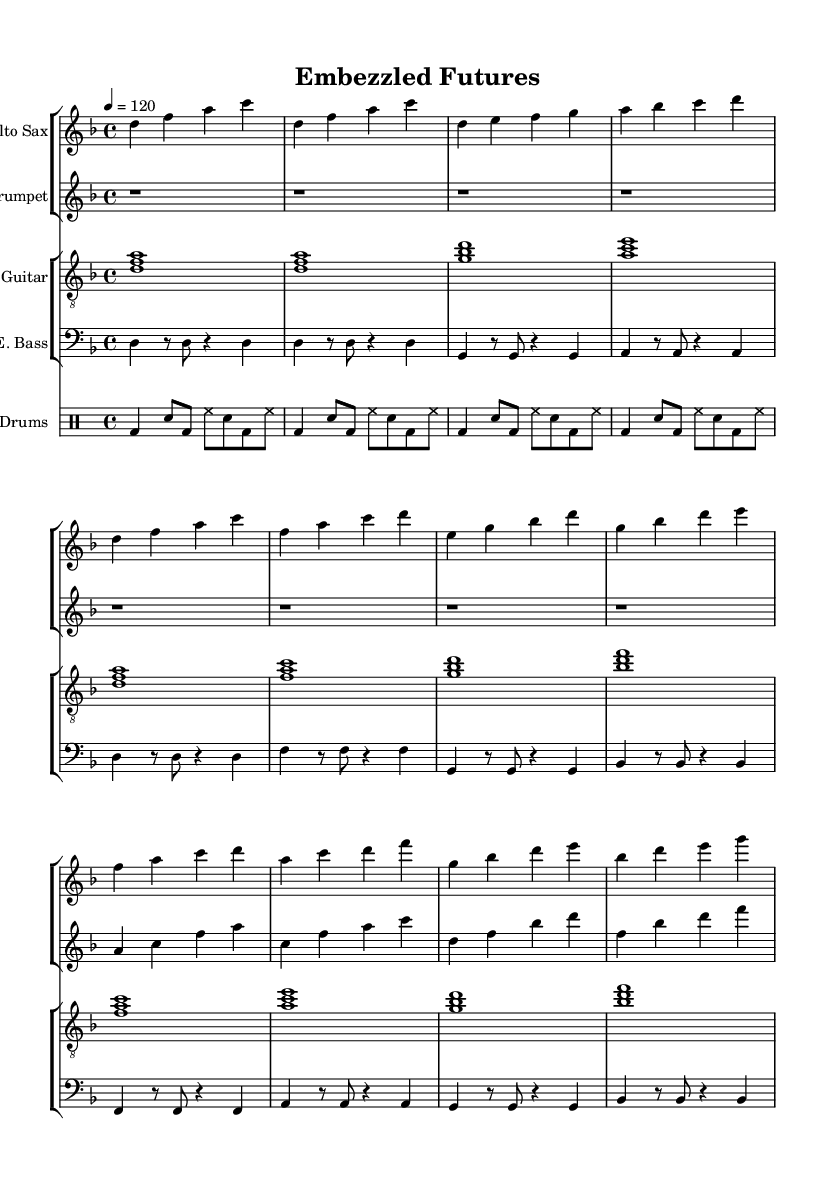What is the key signature of this music? The key signature is identified at the beginning of the score where one sharp is present, indicating D minor.
Answer: D minor What is the time signature of this music? The time signature is found at the beginning of the score, where it is indicated as a 4 over 4, meaning there are four beats in each measure.
Answer: 4/4 What is the tempo marking of this piece? The tempo marking is stated at the beginning as a quarter note equals 120, which indicates the speed of the performance.
Answer: 120 How many measures are in the verse section? By analyzing the verse section in the music, I count four measures dedicated to the verse, as indicated in the score.
Answer: 4 What is the primary genre fusion of this piece? The title "Embezzled Futures" and the instrumentation suggest a blend of Afrobeat and jazz elements as typical of Afrobeat-jazz fusion.
Answer: Afrobeat-jazz fusion What instrument plays the melody in the chorus? By looking at the chorus section, it is evident that the alto saxophone carries the melody during that part of the composition.
Answer: Alto saxophone What rhythmic pattern is used for the drums? The drum section employs a basic Afrobeat-inspired pattern characterized by the alternating bass and snare hits, creating a signature groove.
Answer: Afrobeat-inspired pattern 